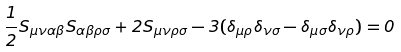<formula> <loc_0><loc_0><loc_500><loc_500>\frac { 1 } { 2 } S _ { \mu \nu \alpha \beta } S _ { \alpha \beta \rho \sigma } + 2 S _ { \mu \nu \rho \sigma } - 3 ( \delta _ { \mu \rho } \delta _ { \nu \sigma } - \delta _ { \mu \sigma } \delta _ { \nu \rho } ) = 0</formula> 